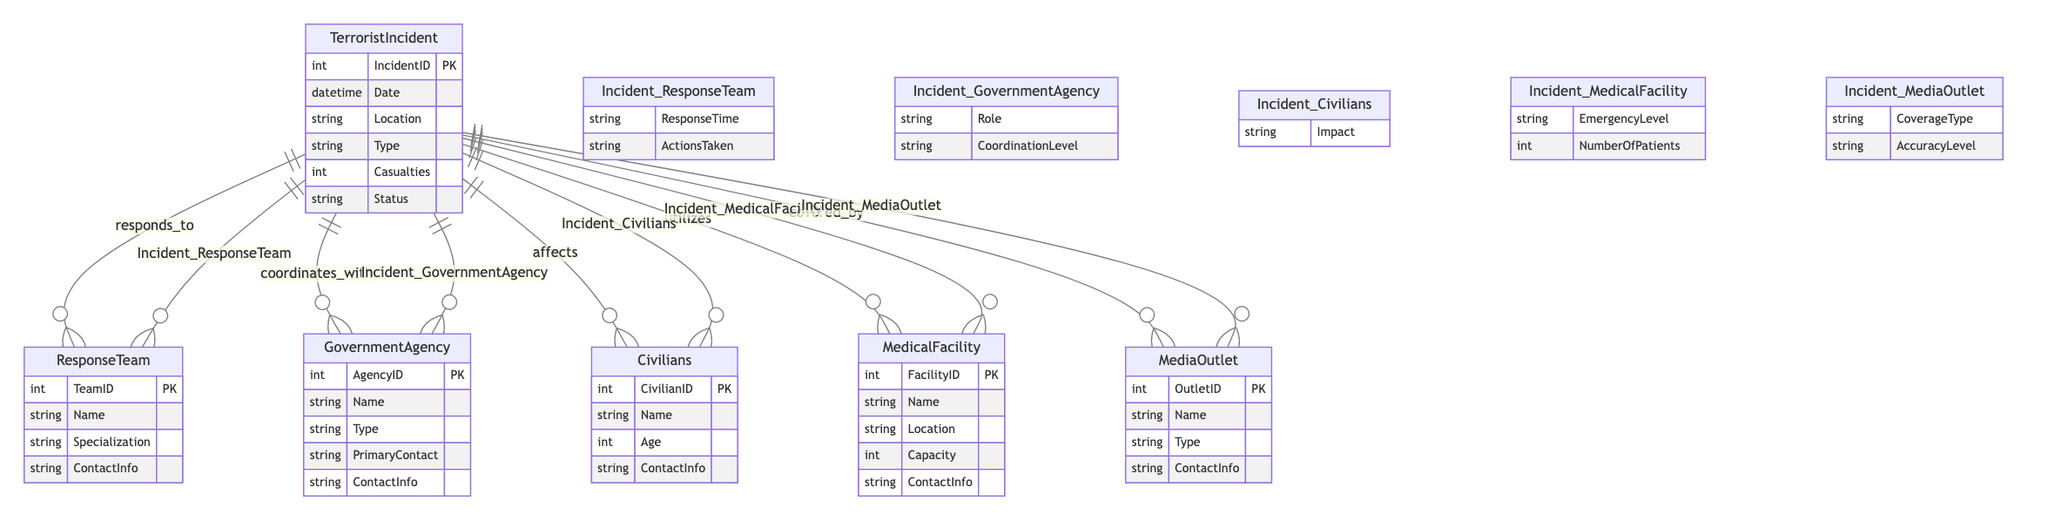What is the primary key of the Terrorist Incident entity? The primary key of the Terrorist Incident entity is IncidentID, which uniquely identifies each incident in the database.
Answer: IncidentID How many attributes are there for the Government Agency entity? The Government Agency entity has five attributes: AgencyID, Name, Type, PrimaryContact, and ContactInfo.
Answer: Five What type of relationship exists between TerroristIncident and ResponseTeam? The relationship between TerroristIncident and ResponseTeam is many-to-many. This indicates that multiple response teams can respond to a single incident and each team can respond to multiple incidents.
Answer: Many-to-Many What is the role attribute in the Incident_GovernmentAgency relationship? The role attribute describes the specific function or duty that the government agency has in response to a specific terrorist incident, indicating their involvement and responsibilities.
Answer: Role Which entity has a one-to-many relationship with TerroristIncident? The Civilians entity has a one-to-many relationship with TerroristIncident, meaning that each incident can affect multiple civilians, but each civilian is associated with only one incident.
Answer: Civilians What could be a possible value for the status attribute in the TerroristIncident entity? The status attribute in the TerroristIncident entity could have possible values such as ongoing or resolved, indicating the current state of the incident.
Answer: Ongoing How does the NumberOfPatients attribute relate to the MedicalFacility? The NumberOfPatients attribute in the Incident_MedicalFacility relationship describes how many patients were admitted to a medical facility as a result of the terrorist incident, reflecting the facility's response capacity.
Answer: NumberOfPatients Which entity is represented that provides coverage of the terrorist incident? The entity that provides coverage of the terrorist incident is MediaOutlet, reflecting the involvement of various media organizations in reporting about the incident.
Answer: MediaOutlet What is the significance of the ResponseTime attribute in the Incident_ResponseTeam relationship? The ResponseTime attribute indicates the time taken for a specific response team to respond to a terrorist incident, which is a critical measure of their efficiency and operational readiness.
Answer: ResponseTime 